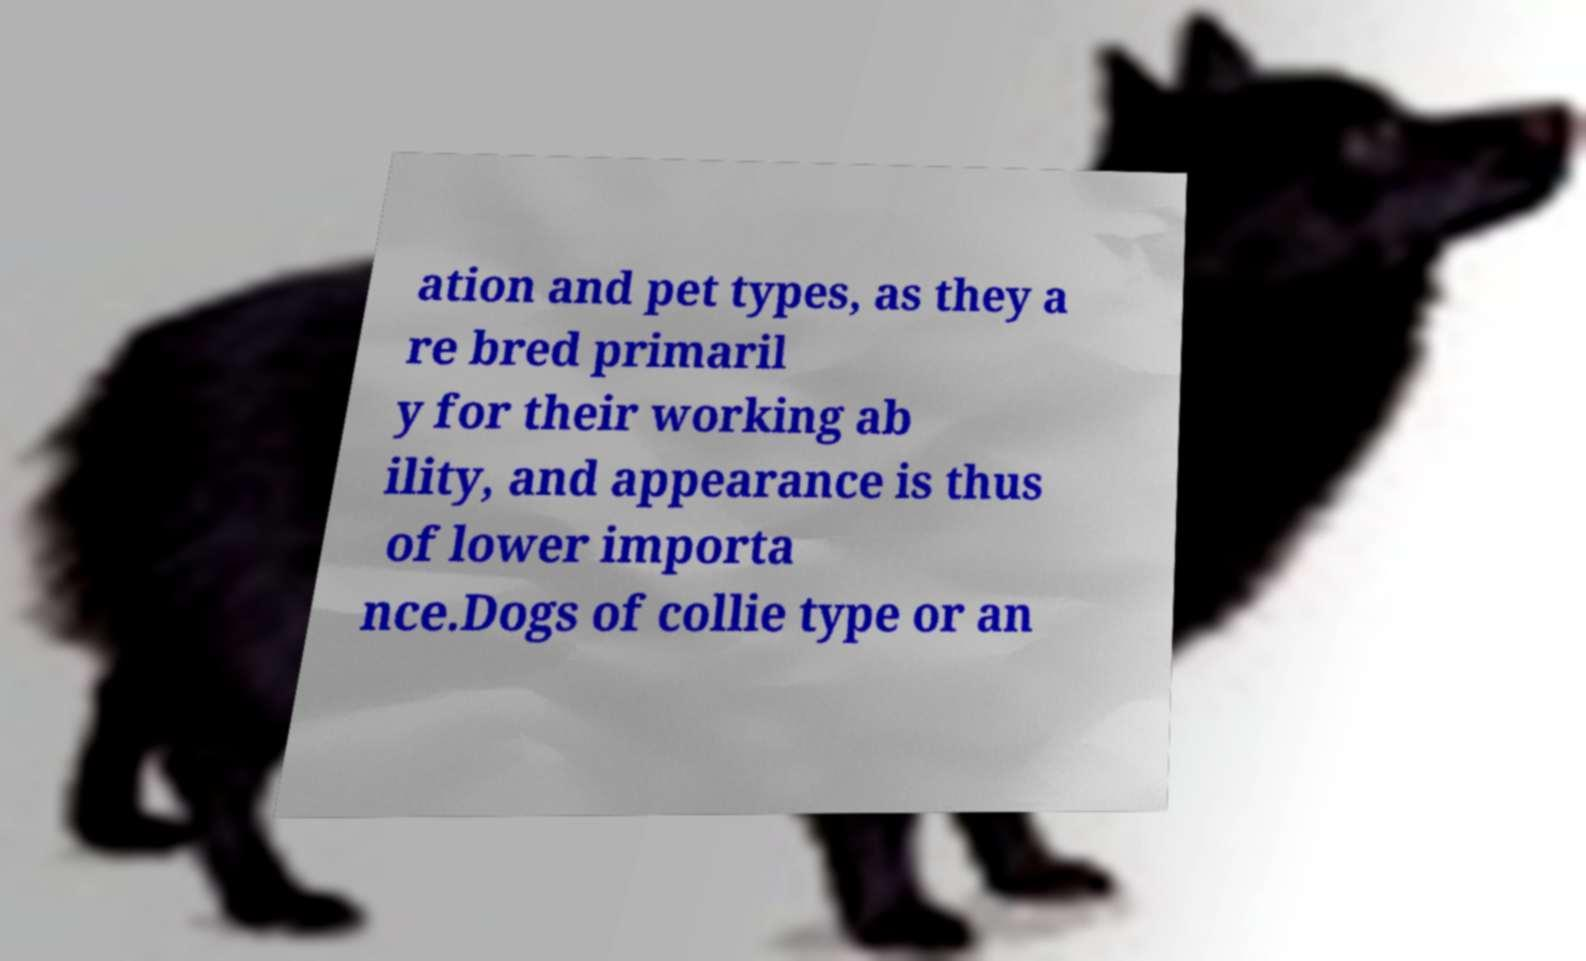For documentation purposes, I need the text within this image transcribed. Could you provide that? ation and pet types, as they a re bred primaril y for their working ab ility, and appearance is thus of lower importa nce.Dogs of collie type or an 